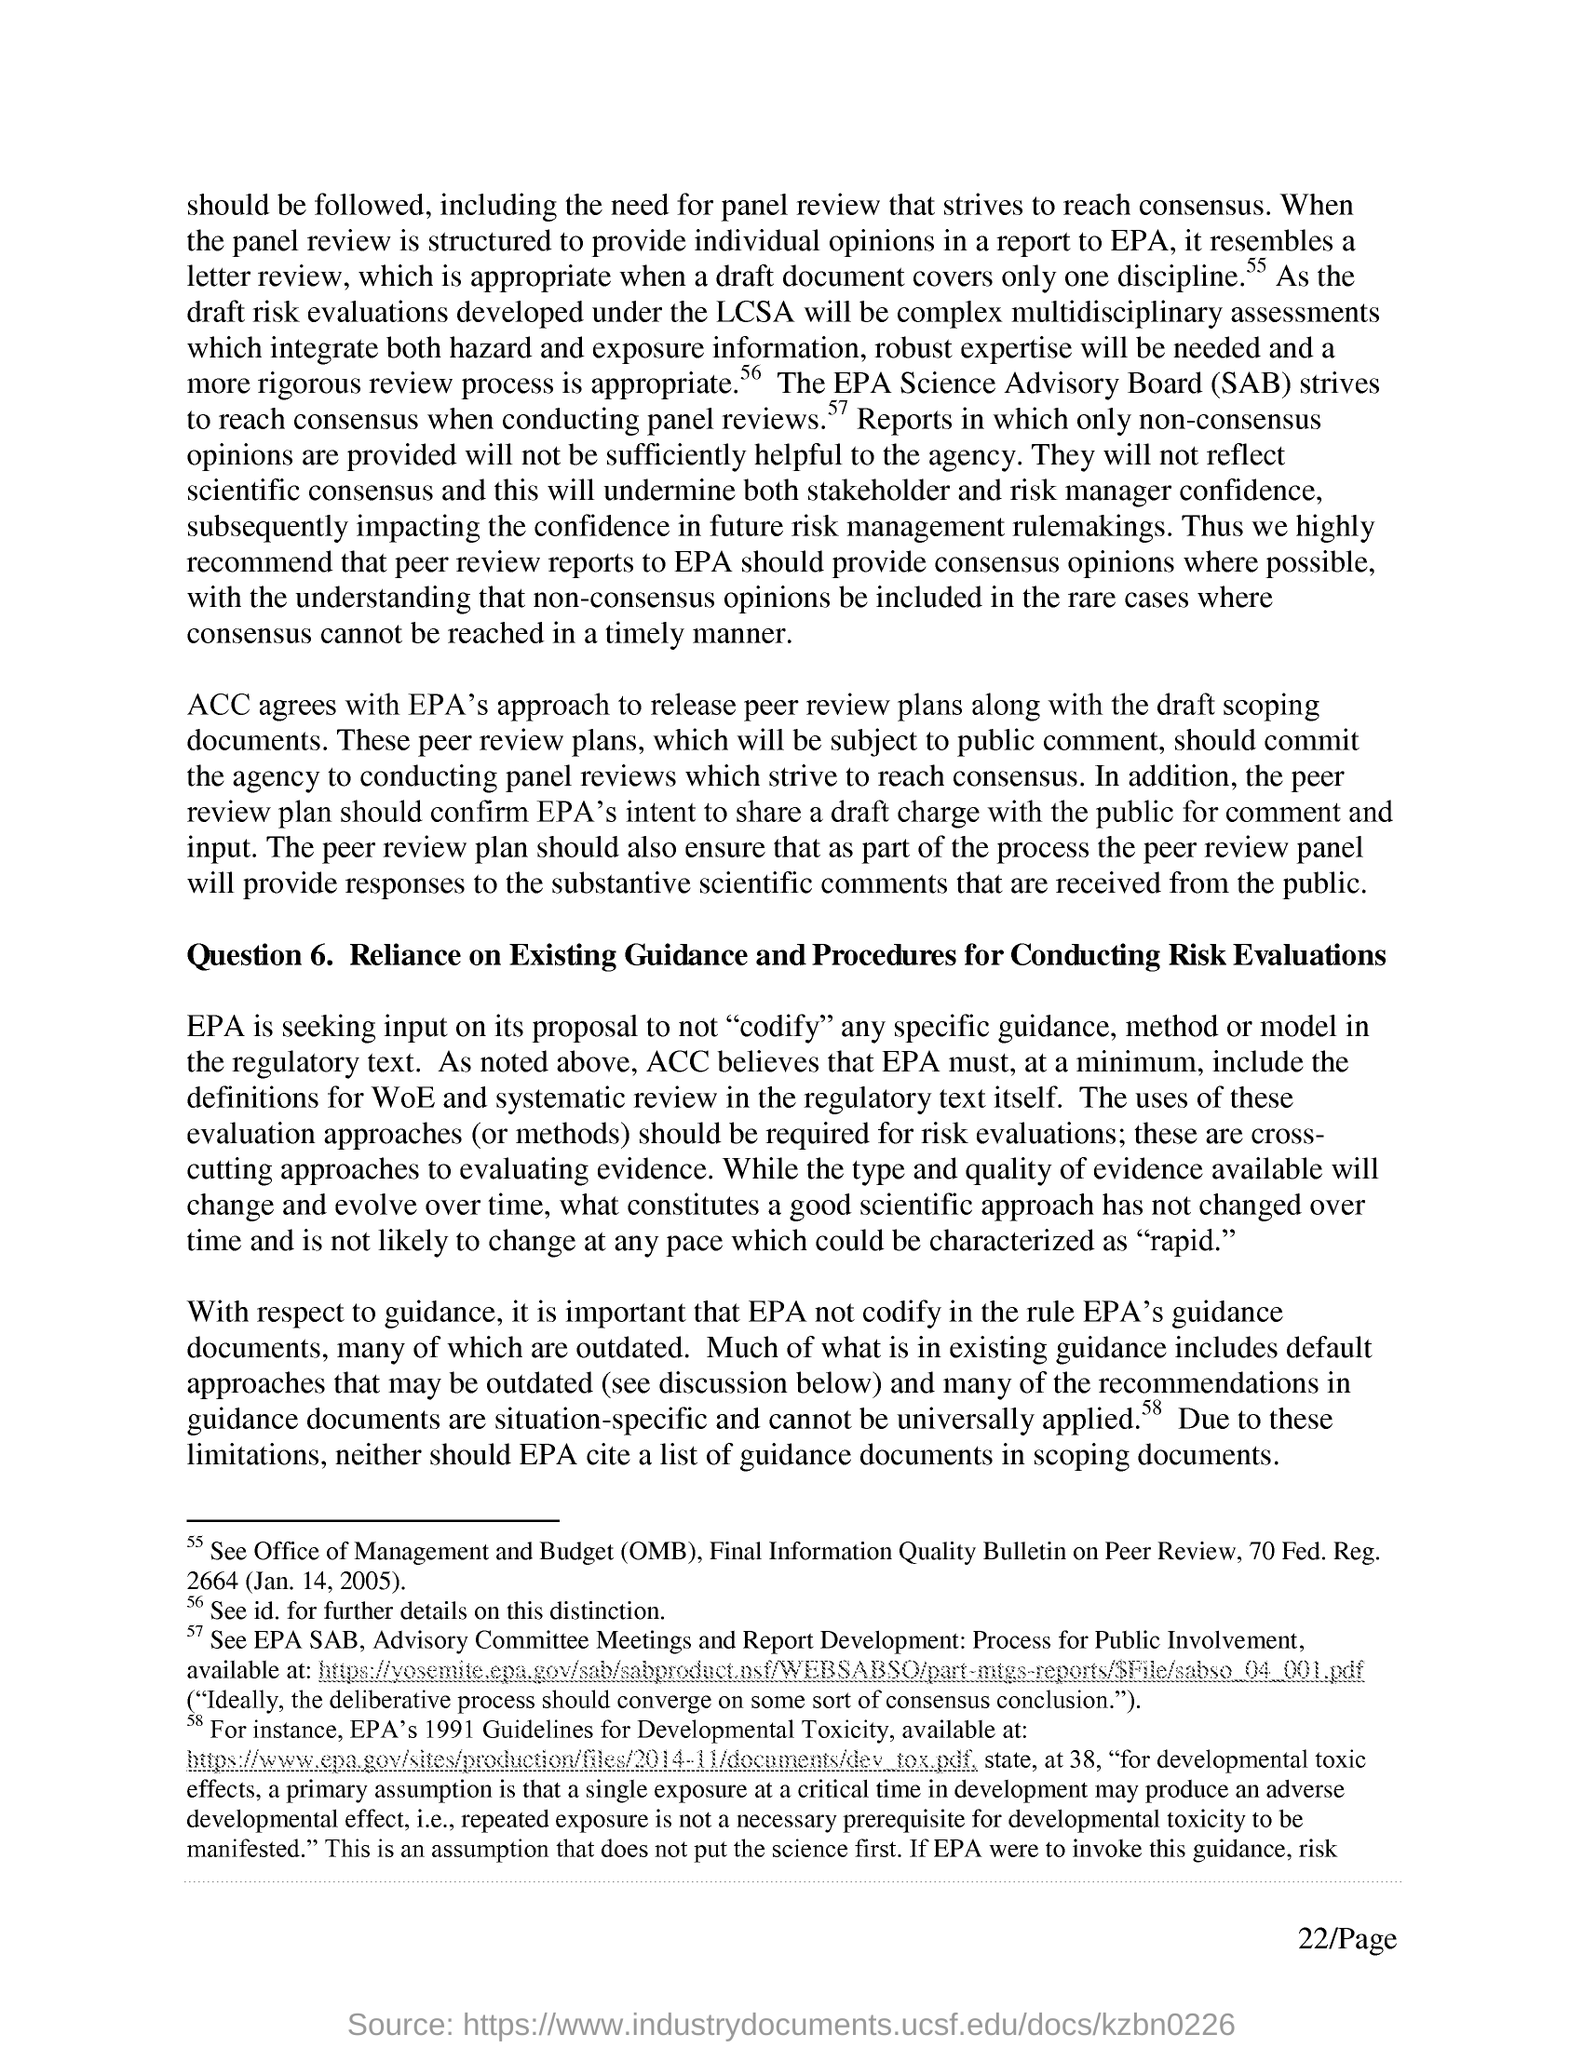Give some essential details in this illustration. The Office of Management and Budget (OMB) is a federal agency responsible for managing the government's budget and overseeing government programs. 